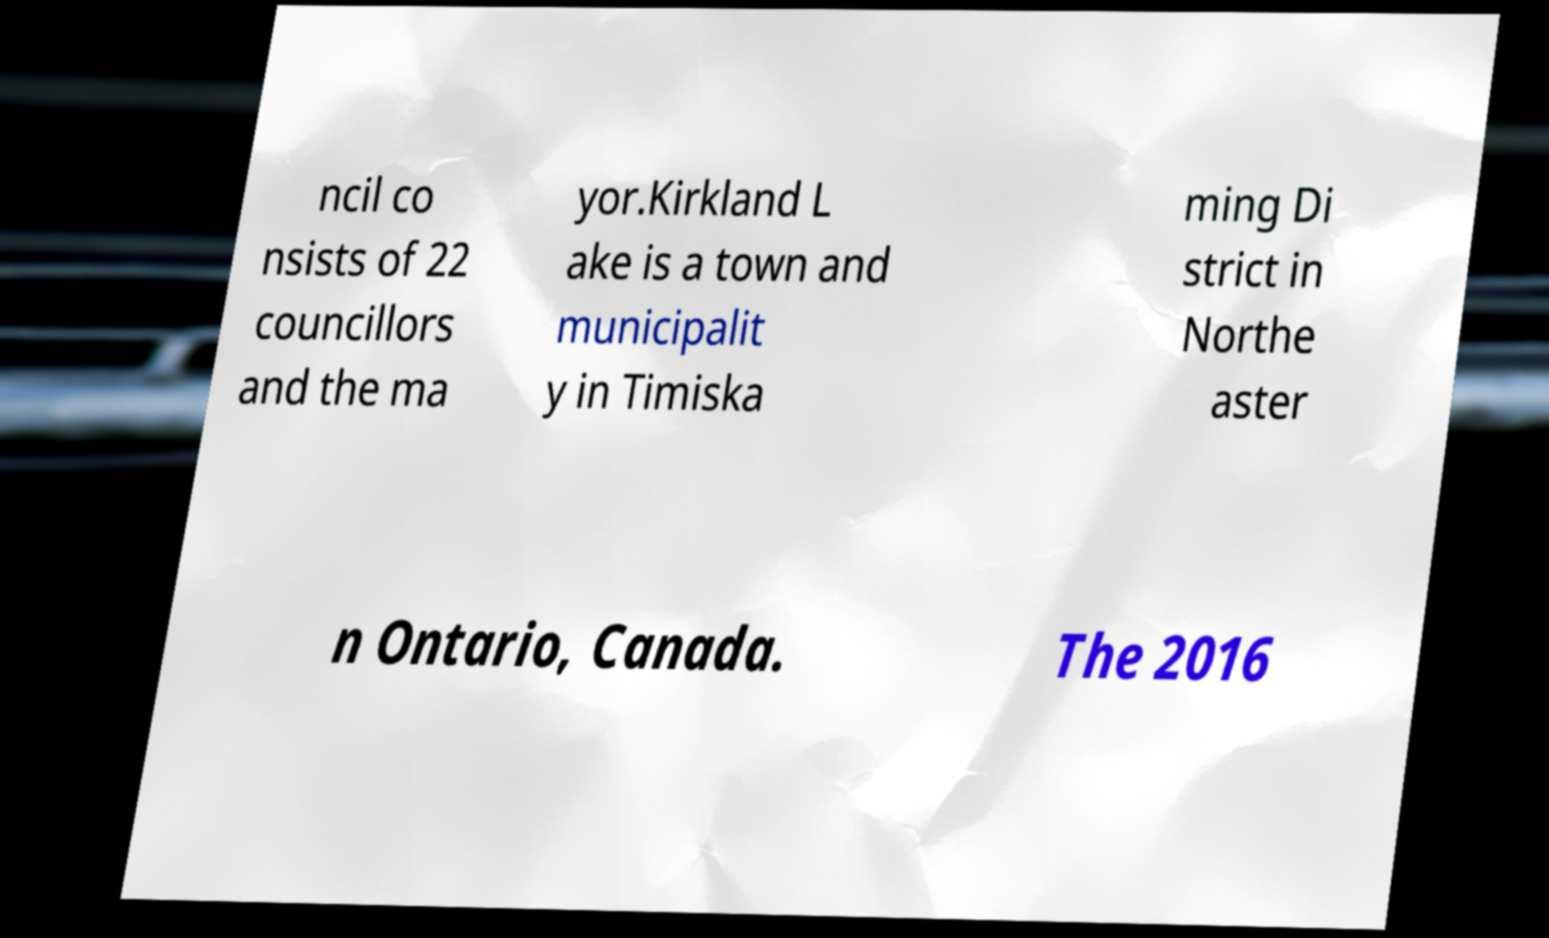I need the written content from this picture converted into text. Can you do that? ncil co nsists of 22 councillors and the ma yor.Kirkland L ake is a town and municipalit y in Timiska ming Di strict in Northe aster n Ontario, Canada. The 2016 